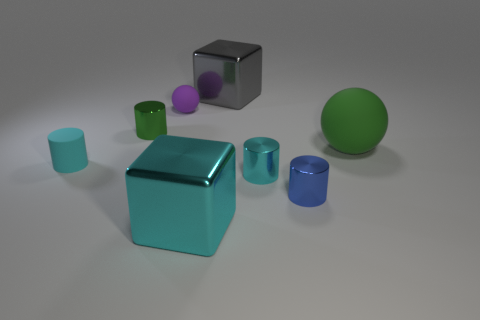What number of other things are the same shape as the green matte object?
Your answer should be very brief. 1. What color is the rubber cylinder that is the same size as the cyan metallic cylinder?
Offer a very short reply. Cyan. Are there an equal number of gray cubes left of the large gray block and big blue metallic things?
Your answer should be very brief. Yes. There is a metallic thing that is to the right of the gray thing and in front of the tiny cyan shiny cylinder; what shape is it?
Provide a succinct answer. Cylinder. Does the blue metallic object have the same size as the purple sphere?
Provide a succinct answer. Yes. Are there any green balls that have the same material as the purple sphere?
Offer a very short reply. Yes. What is the size of the metallic cube that is the same color as the tiny rubber cylinder?
Your response must be concise. Large. What number of large things are in front of the tiny matte ball and to the left of the blue metal cylinder?
Your answer should be very brief. 1. There is a sphere that is to the left of the large gray block; what is it made of?
Your response must be concise. Rubber. How many metallic things have the same color as the large rubber sphere?
Ensure brevity in your answer.  1. 